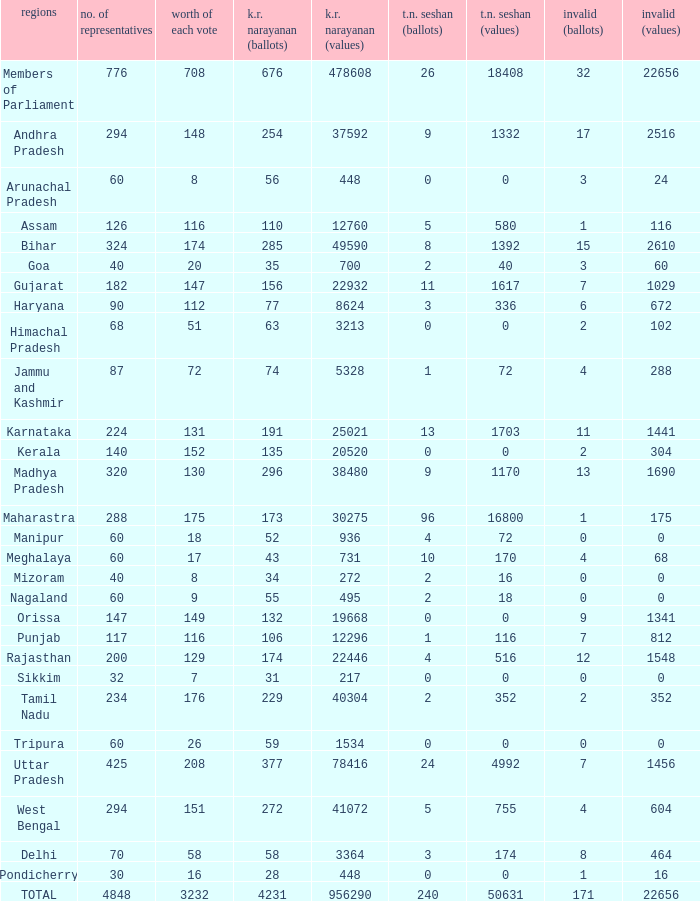Name the most kr votes for value of each vote for 208 377.0. 